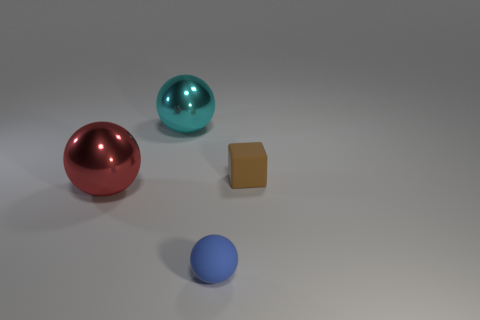Is there another rubber sphere that has the same size as the blue sphere? No, there isn’t another sphere of the same size as the blue sphere. Each sphere in the image has a unique size. The red sphere is the largest, followed by the teal sphere, and the blue sphere is the smallest. 